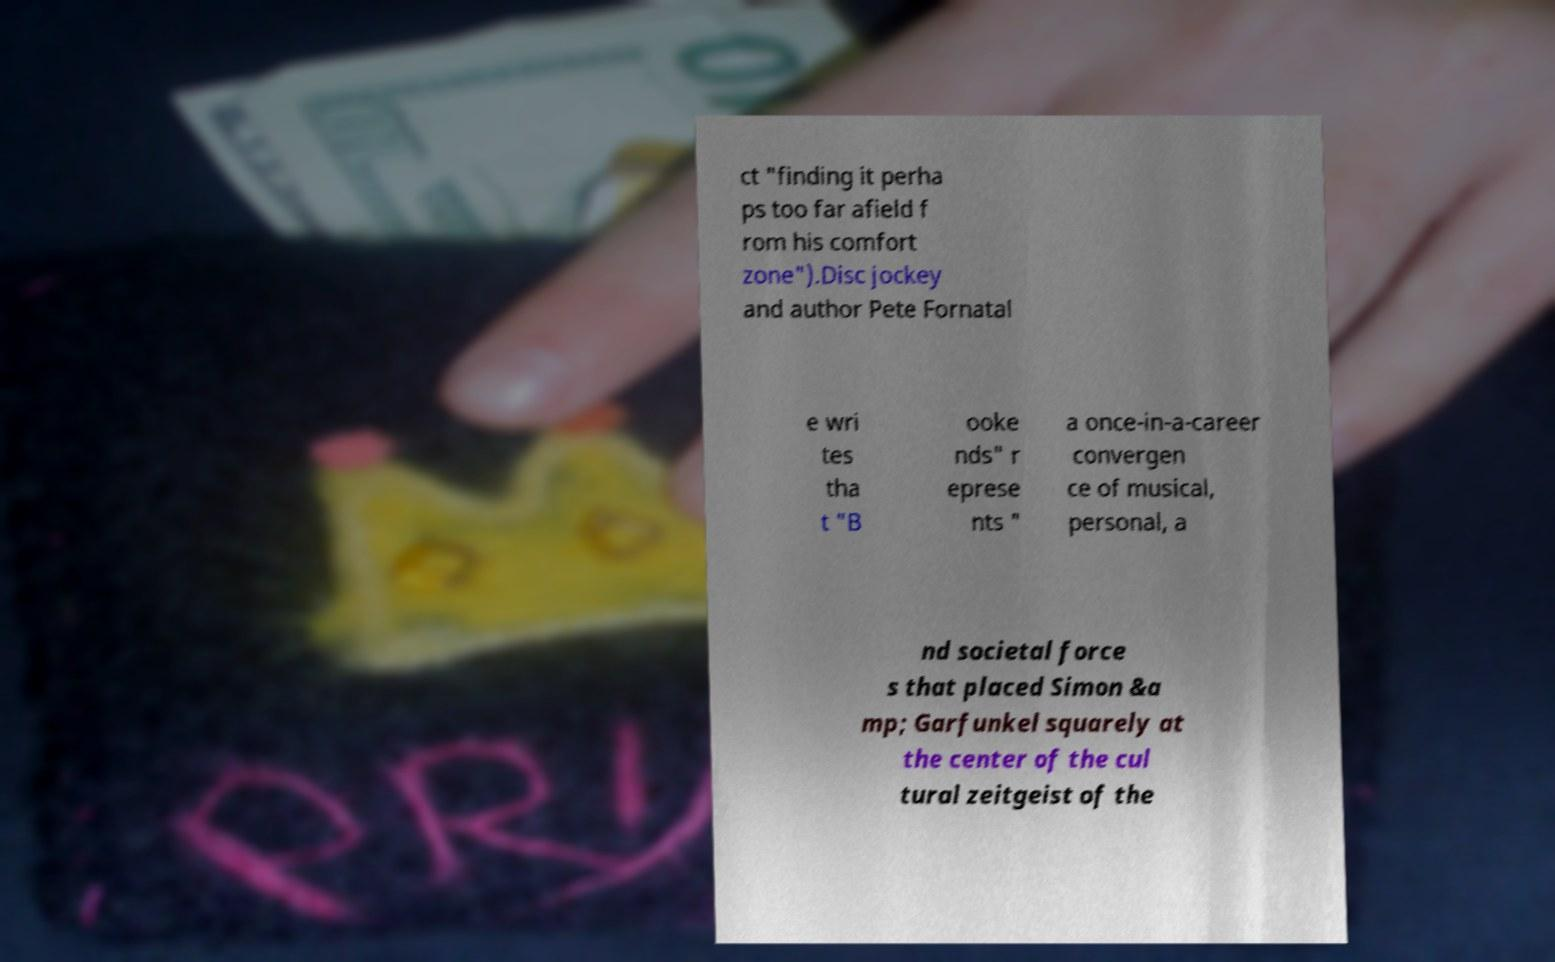For documentation purposes, I need the text within this image transcribed. Could you provide that? ct "finding it perha ps too far afield f rom his comfort zone").Disc jockey and author Pete Fornatal e wri tes tha t "B ooke nds" r eprese nts " a once-in-a-career convergen ce of musical, personal, a nd societal force s that placed Simon &a mp; Garfunkel squarely at the center of the cul tural zeitgeist of the 